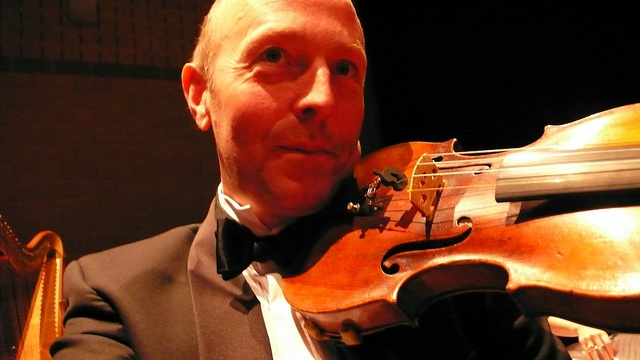Describe the objects in this image and their specific colors. I can see people in black, maroon, and brown tones and tie in black, maroon, and brown tones in this image. 